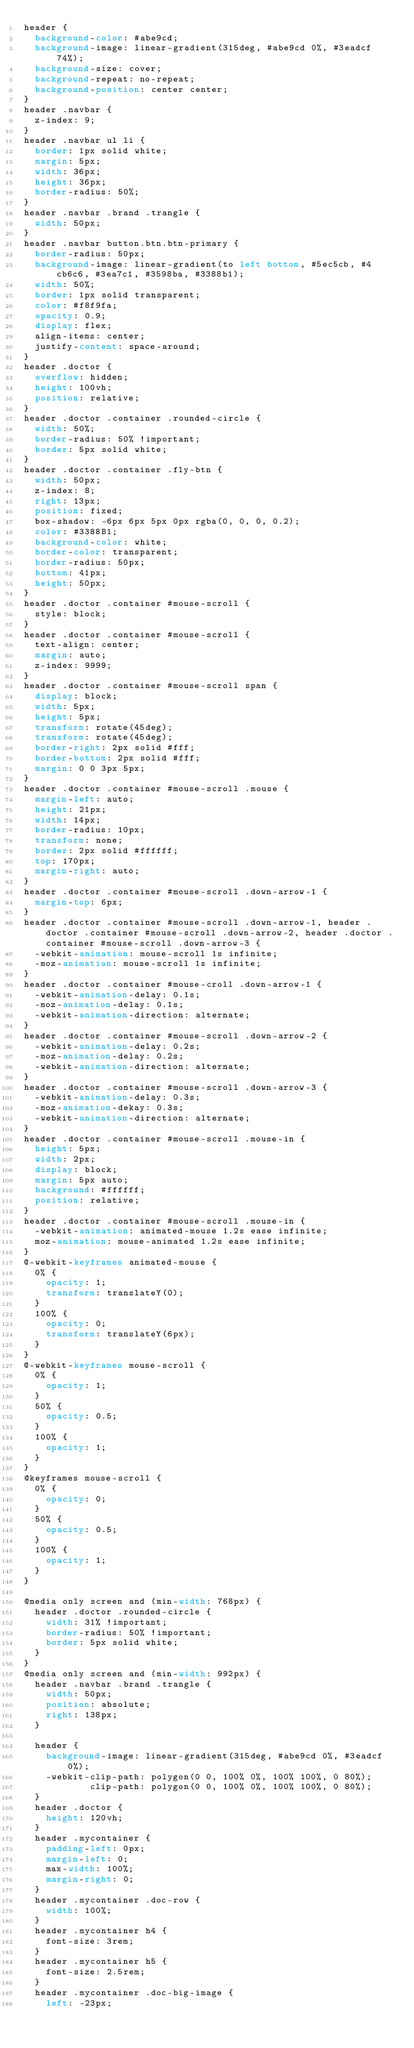<code> <loc_0><loc_0><loc_500><loc_500><_CSS_>header {
  background-color: #abe9cd;
  background-image: linear-gradient(315deg, #abe9cd 0%, #3eadcf 74%);
  background-size: cover;
  background-repeat: no-repeat;
  background-position: center center;
}
header .navbar {
  z-index: 9;
}
header .navbar ul li {
  border: 1px solid white;
  margin: 5px;
  width: 36px;
  height: 36px;
  border-radius: 50%;
}
header .navbar .brand .trangle {
  width: 50px;
}
header .navbar button.btn.btn-primary {
  border-radius: 50px;
  background-image: linear-gradient(to left bottom, #5ec5cb, #4cb6c6, #3ea7c1, #3598ba, #3388b1);
  width: 50%;
  border: 1px solid transparent;
  color: #f8f9fa;
  opacity: 0.9;
  display: flex;
  align-items: center;
  justify-content: space-around;
}
header .doctor {
  overflow: hidden;
  height: 100vh;
  position: relative;
}
header .doctor .container .rounded-circle {
  width: 50%;
  border-radius: 50% !important;
  border: 5px solid white;
}
header .doctor .container .fly-btn {
  width: 50px;
  z-index: 8;
  right: 13px;
  position: fixed;
  box-shadow: -6px 6px 5px 0px rgba(0, 0, 0, 0.2);
  color: #3388B1;
  background-color: white;
  border-color: transparent;
  border-radius: 50px;
  bottom: 41px;
  height: 50px;
}
header .doctor .container #mouse-scroll {
  style: block;
}
header .doctor .container #mouse-scroll {
  text-align: center;
  margin: auto;
  z-index: 9999;
}
header .doctor .container #mouse-scroll span {
  display: block;
  width: 5px;
  height: 5px;
  transform: rotate(45deg);
  transform: rotate(45deg);
  border-right: 2px solid #fff;
  border-bottom: 2px solid #fff;
  margin: 0 0 3px 5px;
}
header .doctor .container #mouse-scroll .mouse {
  margin-left: auto;
  height: 21px;
  width: 14px;
  border-radius: 10px;
  transform: none;
  border: 2px solid #ffffff;
  top: 170px;
  margin-right: auto;
}
header .doctor .container #mouse-scroll .down-arrow-1 {
  margin-top: 6px;
}
header .doctor .container #mouse-scroll .down-arrow-1, header .doctor .container #mouse-scroll .down-arrow-2, header .doctor .container #mouse-scroll .down-arrow-3 {
  -webkit-animation: mouse-scroll 1s infinite;
  -moz-animation: mouse-scroll 1s infinite;
}
header .doctor .container #mouse-croll .down-arrow-1 {
  -webkit-animation-delay: 0.1s;
  -moz-animation-delay: 0.1s;
  -webkit-animation-direction: alternate;
}
header .doctor .container #mouse-scroll .down-arrow-2 {
  -webkit-animation-delay: 0.2s;
  -moz-animation-delay: 0.2s;
  -webkit-animation-direction: alternate;
}
header .doctor .container #mouse-scroll .down-arrow-3 {
  -webkit-animation-delay: 0.3s;
  -moz-animation-dekay: 0.3s;
  -webkit-animation-direction: alternate;
}
header .doctor .container #mouse-scroll .mouse-in {
  height: 5px;
  width: 2px;
  display: block;
  margin: 5px auto;
  background: #ffffff;
  position: relative;
}
header .doctor .container #mouse-scroll .mouse-in {
  -webkit-animation: animated-mouse 1.2s ease infinite;
  moz-animation: mouse-animated 1.2s ease infinite;
}
@-webkit-keyframes animated-mouse {
  0% {
    opacity: 1;
    transform: translateY(0);
  }
  100% {
    opacity: 0;
    transform: translateY(6px);
  }
}
@-webkit-keyframes mouse-scroll {
  0% {
    opacity: 1;
  }
  50% {
    opacity: 0.5;
  }
  100% {
    opacity: 1;
  }
}
@keyframes mouse-scroll {
  0% {
    opacity: 0;
  }
  50% {
    opacity: 0.5;
  }
  100% {
    opacity: 1;
  }
}

@media only screen and (min-width: 768px) {
  header .doctor .rounded-circle {
    width: 31% !important;
    border-radius: 50% !important;
    border: 5px solid white;
  }
}
@media only screen and (min-width: 992px) {
  header .navbar .brand .trangle {
    width: 50px;
    position: absolute;
    right: 138px;
  }

  header {
    background-image: linear-gradient(315deg, #abe9cd 0%, #3eadcf 0%);
    -webkit-clip-path: polygon(0 0, 100% 0%, 100% 100%, 0 80%);
            clip-path: polygon(0 0, 100% 0%, 100% 100%, 0 80%);
  }
  header .doctor {
    height: 120vh;
  }
  header .mycontainer {
    padding-left: 0px;
    margin-left: 0;
    max-width: 100%;
    margin-right: 0;
  }
  header .mycontainer .doc-row {
    width: 100%;
  }
  header .mycontainer h4 {
    font-size: 3rem;
  }
  header .mycontainer h5 {
    font-size: 2.5rem;
  }
  header .mycontainer .doc-big-image {
    left: -23px;</code> 